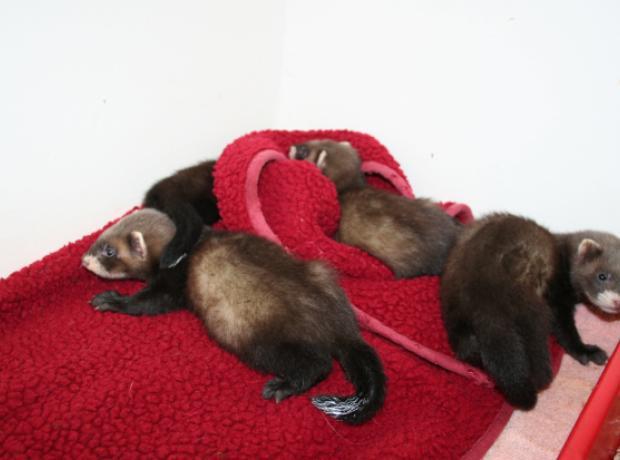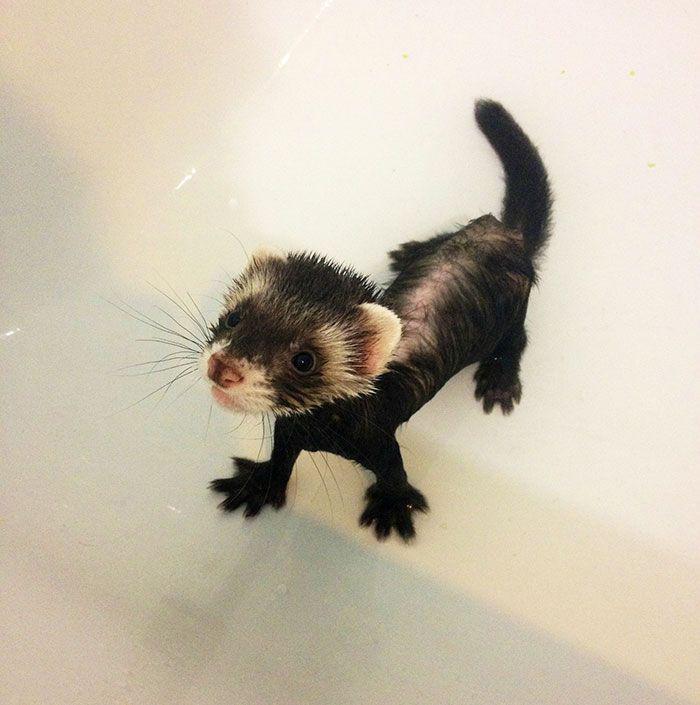The first image is the image on the left, the second image is the image on the right. For the images shown, is this caption "The animal in the image on the left is wearing an article of clothing." true? Answer yes or no. No. The first image is the image on the left, the second image is the image on the right. Analyze the images presented: Is the assertion "The single ferret on the left hand side is dressed up with an accessory while the right hand image shows exactly two ferrets." valid? Answer yes or no. No. 